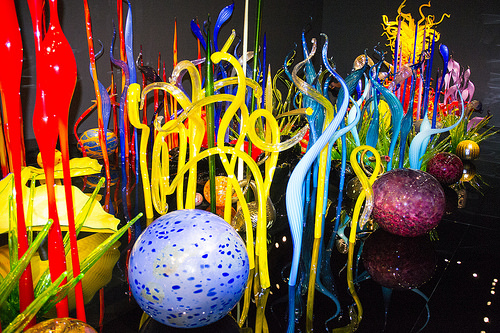<image>
Is there a bird next to the ball? No. The bird is not positioned next to the ball. They are located in different areas of the scene. 